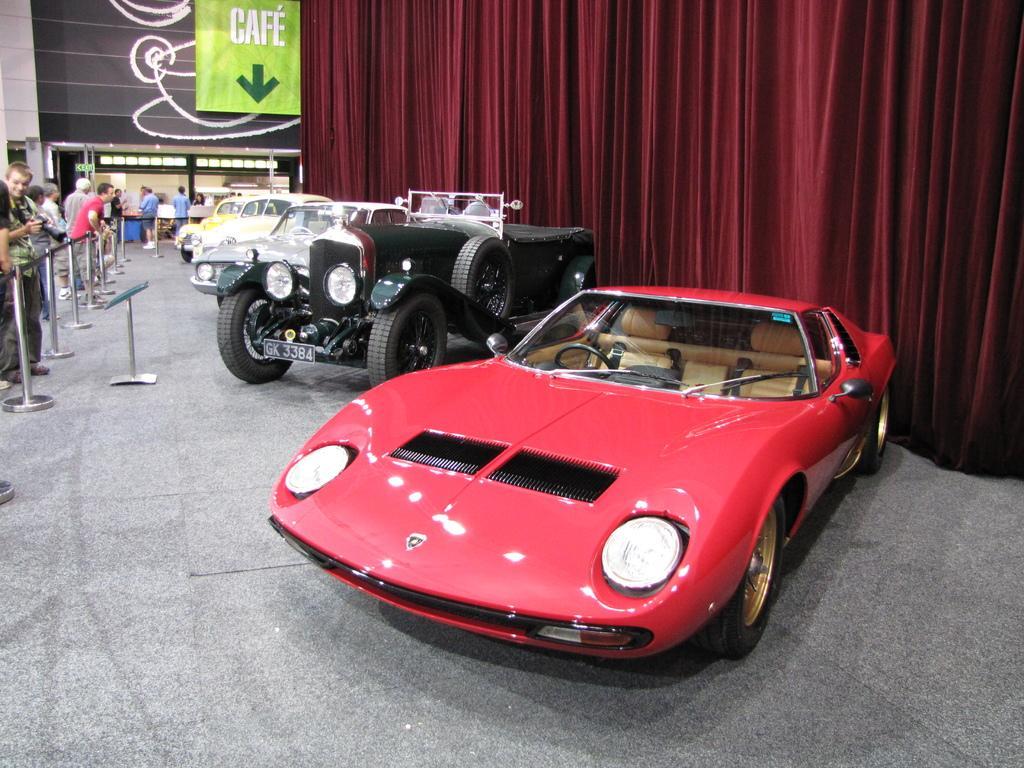Describe this image in one or two sentences. In this image we can see some vehicles parked on the ground. On the left side of the image we can see some poles and ropes, a group of people standing on the ground. One man is holding the camera in his hand. On the right side of the image we can see the curtains. At the top of the image we can see a board with some text. 